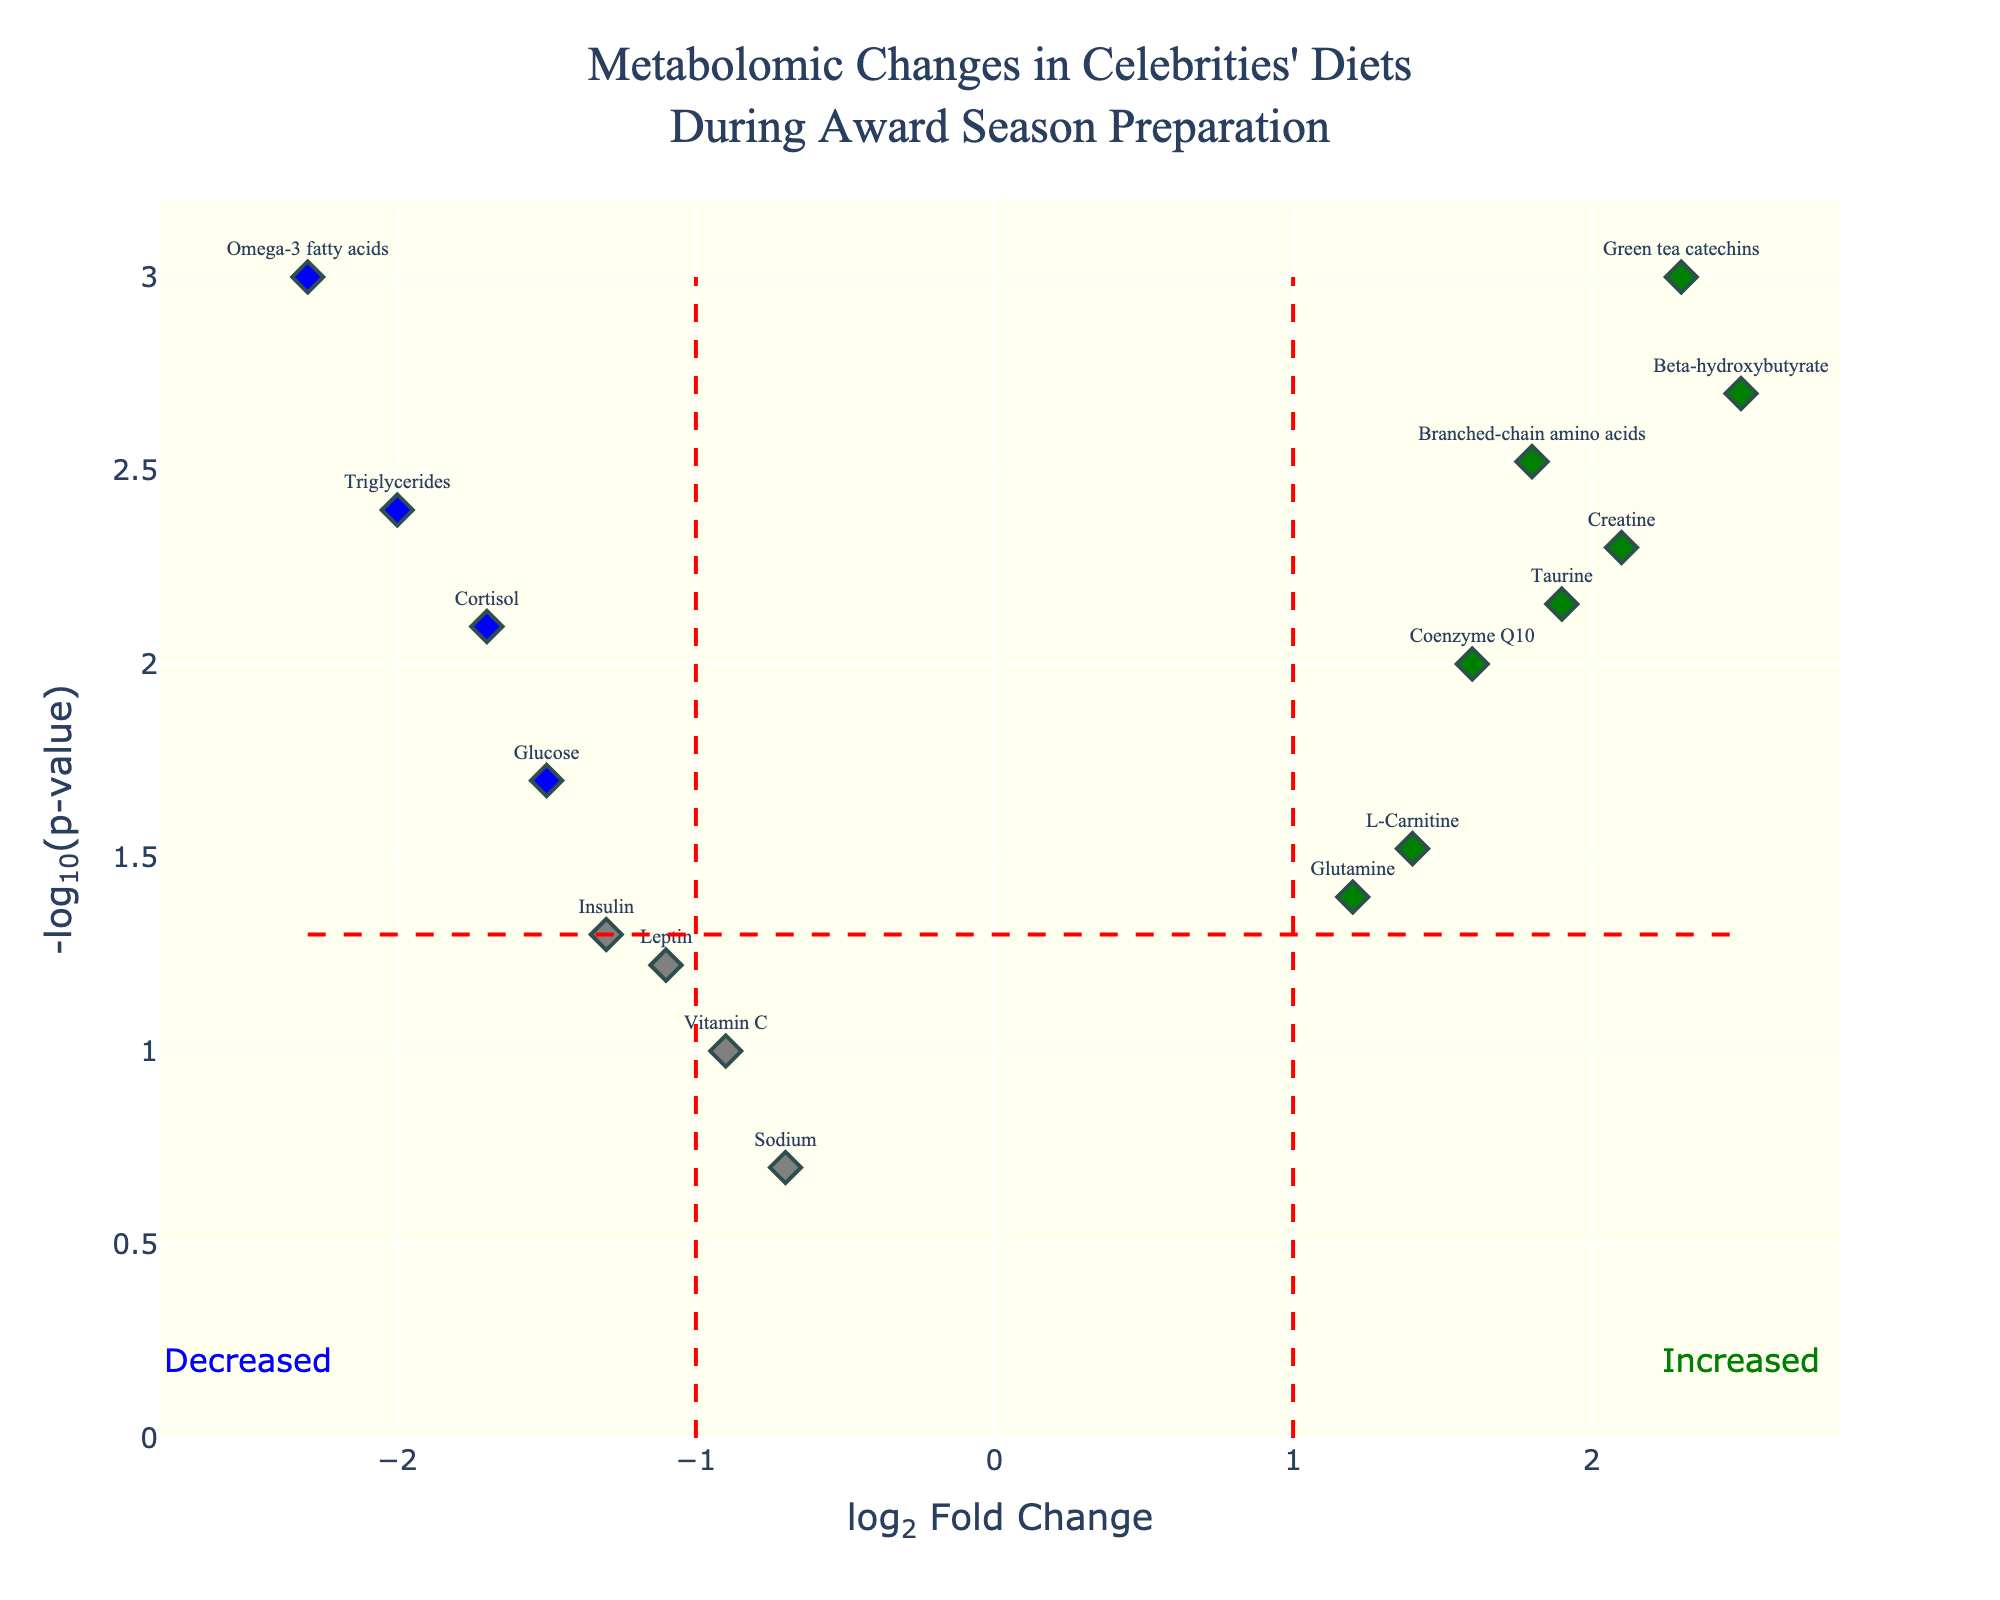Which metabolite has the highest -log10(p-value)? To find the metabolite with the highest -log10(p-value), look for the highest point on the y-axis of the plot.
Answer: Omega-3 fatty acids How many metabolites are marked with green color? Green color indicates metabolites that are significantly increased. Count all the green markers in the plot.
Answer: 6 What is the log2 Fold Change (log2FC) value of Omega-3 fatty acids? Identify the point labeled as Omega-3 fatty acids and read its x-axis value for log2FC.
Answer: -2.3 What does the blue color represent in the plot? The blue color represents metabolites that are significantly decreased. This is indicated by a low log2 Fold Change with a significant p-value.
Answer: Significantly decreased Which metabolite shows the greatest increase in log2 Fold Change? Look for the highest positive value on the x-axis. The metabolite at this point is the one with the greatest increase.
Answer: Beta-hydroxybutyrate How many metabolites have a p-value less than 0.01? Identify the points above the -log10(p-value) threshold of 2 (since -log10(0.01) = 2). Count these points.
Answer: 8 Which metabolite has the highest combination of log2FC and -log10(p-value)? High combination means high on both x and y axes. Find the metabolite that is farthest to the top right of the plot.
Answer: Beta-hydroxybutyrate How does the log2FC value of Triglycerides compare to that of Green tea catechins? Compare the x-axis values of Triglycerides and Green tea catechins. Triglycerides has a negative value while Green tea catechins has a positive value.
Answer: Triglycerides is lower What color represents non-significant metabolites? Non-significant metabolites have a p-value greater than 0.05 or an absolute log2FC less than or equal to 1. These points are in gray color.
Answer: Gray What threshold is used for significance in the p-value? The threshold for significance in a p-value is the horizontal line at y = -log10(p-value). The red color lines indicate this threshold.
Answer: 0.05 